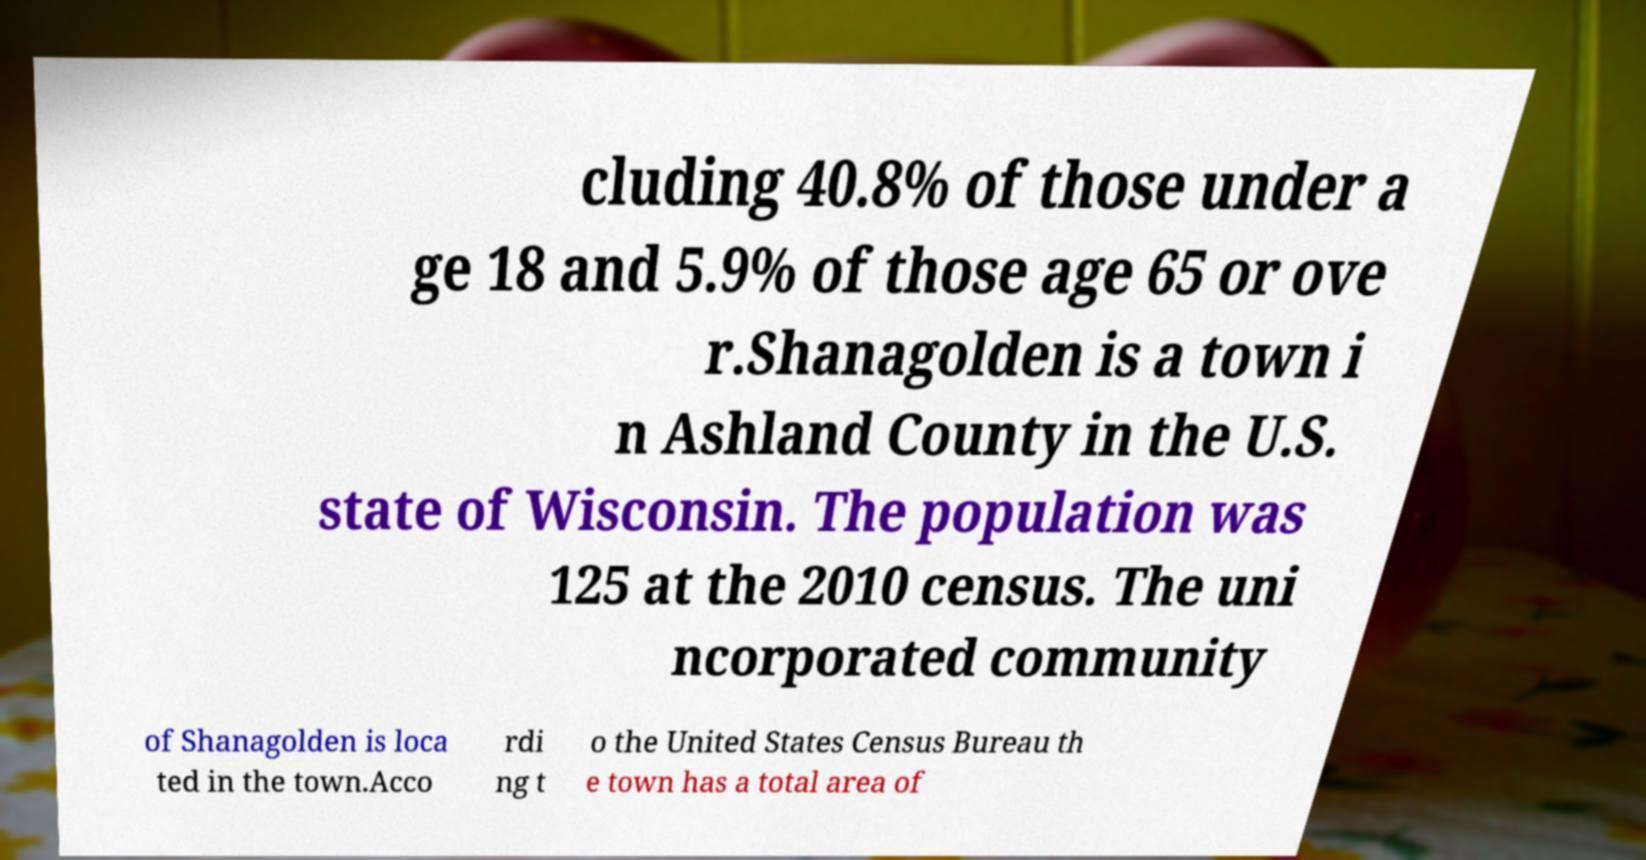Can you accurately transcribe the text from the provided image for me? cluding 40.8% of those under a ge 18 and 5.9% of those age 65 or ove r.Shanagolden is a town i n Ashland County in the U.S. state of Wisconsin. The population was 125 at the 2010 census. The uni ncorporated community of Shanagolden is loca ted in the town.Acco rdi ng t o the United States Census Bureau th e town has a total area of 